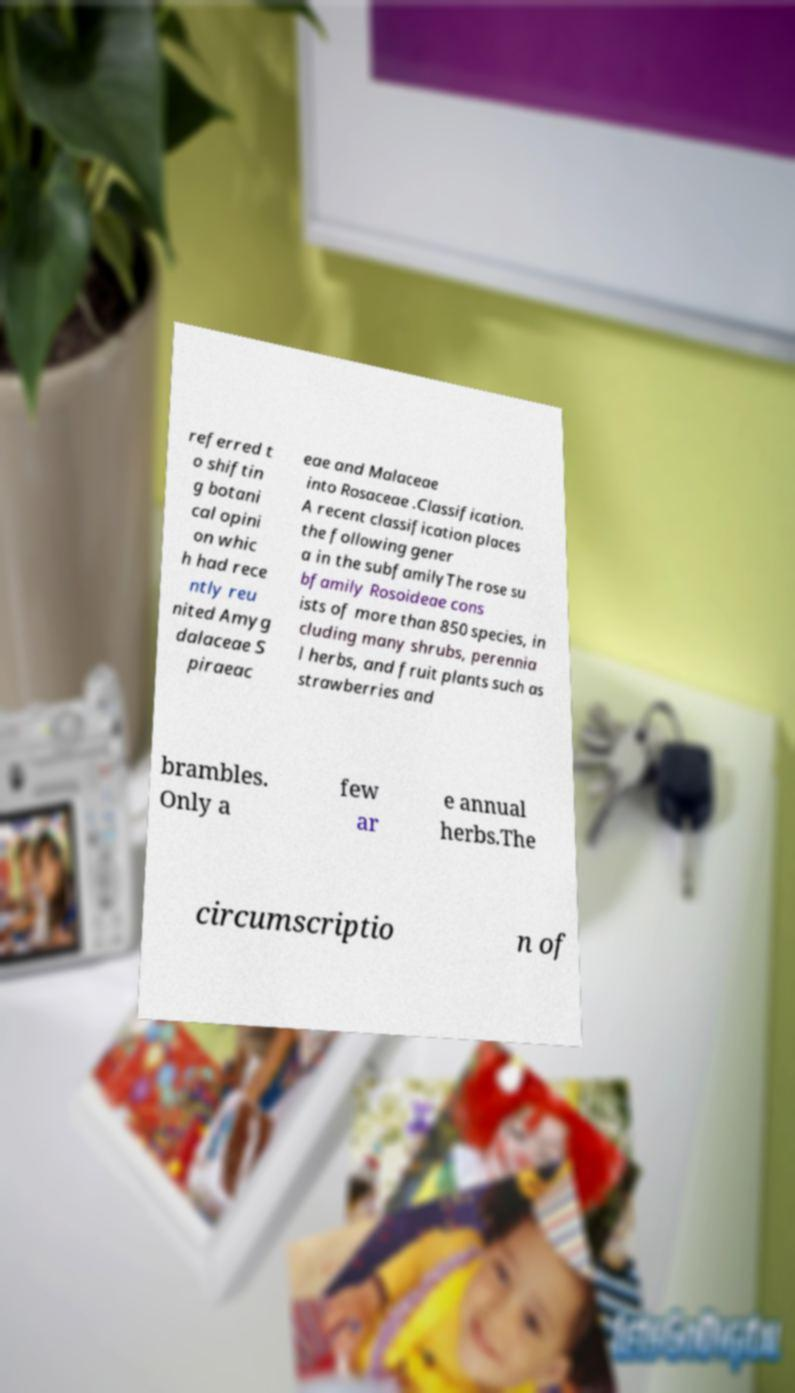Could you assist in decoding the text presented in this image and type it out clearly? referred t o shiftin g botani cal opini on whic h had rece ntly reu nited Amyg dalaceae S piraeac eae and Malaceae into Rosaceae .Classification. A recent classification places the following gener a in the subfamilyThe rose su bfamily Rosoideae cons ists of more than 850 species, in cluding many shrubs, perennia l herbs, and fruit plants such as strawberries and brambles. Only a few ar e annual herbs.The circumscriptio n of 